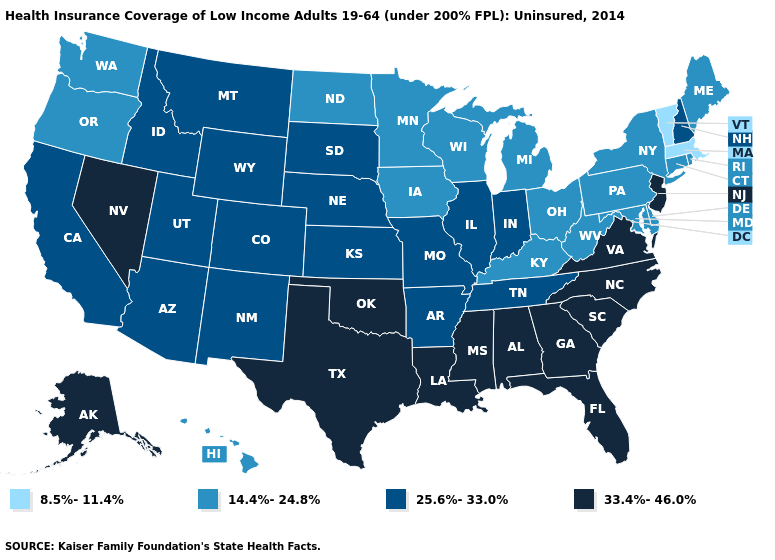What is the value of New York?
Write a very short answer. 14.4%-24.8%. Among the states that border Utah , does Nevada have the highest value?
Give a very brief answer. Yes. Among the states that border Pennsylvania , does New Jersey have the lowest value?
Be succinct. No. What is the value of New Hampshire?
Short answer required. 25.6%-33.0%. Name the states that have a value in the range 33.4%-46.0%?
Quick response, please. Alabama, Alaska, Florida, Georgia, Louisiana, Mississippi, Nevada, New Jersey, North Carolina, Oklahoma, South Carolina, Texas, Virginia. Does the first symbol in the legend represent the smallest category?
Write a very short answer. Yes. What is the value of Oklahoma?
Quick response, please. 33.4%-46.0%. What is the highest value in states that border South Dakota?
Quick response, please. 25.6%-33.0%. What is the value of Virginia?
Concise answer only. 33.4%-46.0%. What is the highest value in states that border California?
Answer briefly. 33.4%-46.0%. Which states have the lowest value in the South?
Keep it brief. Delaware, Kentucky, Maryland, West Virginia. Which states hav the highest value in the West?
Keep it brief. Alaska, Nevada. What is the highest value in the USA?
Keep it brief. 33.4%-46.0%. Name the states that have a value in the range 25.6%-33.0%?
Give a very brief answer. Arizona, Arkansas, California, Colorado, Idaho, Illinois, Indiana, Kansas, Missouri, Montana, Nebraska, New Hampshire, New Mexico, South Dakota, Tennessee, Utah, Wyoming. Does Michigan have the highest value in the USA?
Answer briefly. No. 